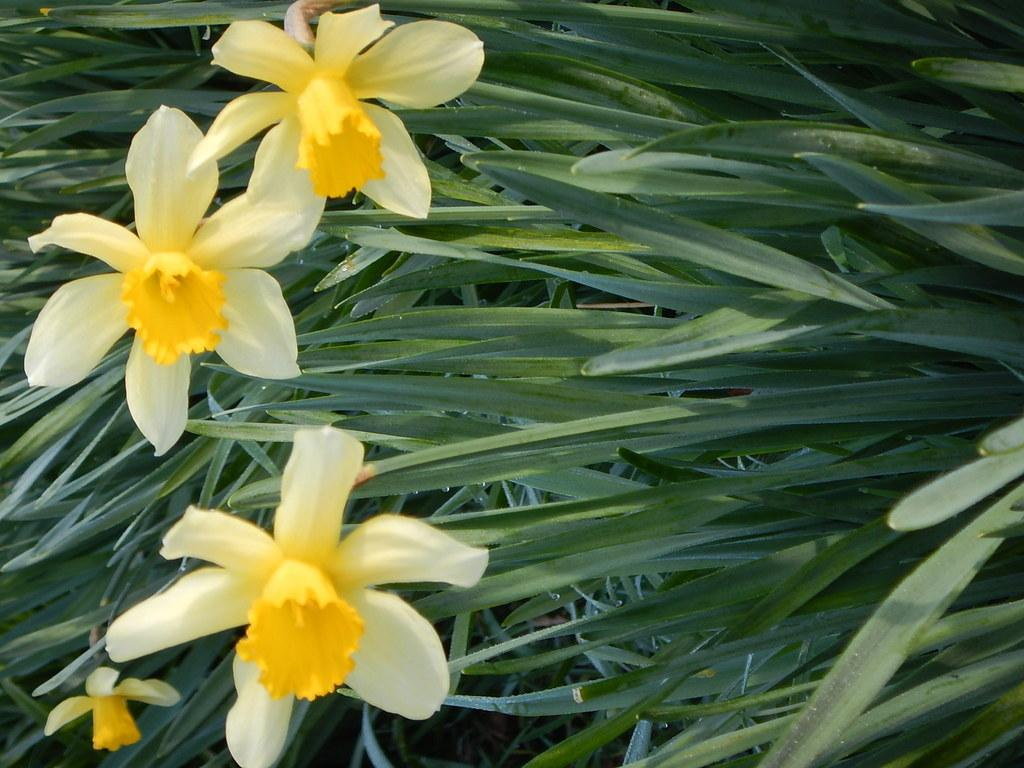What type of plant life is visible in the image? There are flowers and leaves in the image. Can you describe the colors of the flowers in the image? The colors of the flowers in the image cannot be determined without more specific information. What is the context of the image, such as indoors or outdoors? The context of the image cannot be determined without more information. What type of knife is being used to cut the muscle in the image? There is no knife or muscle present in the image; it only features flowers and leaves. 